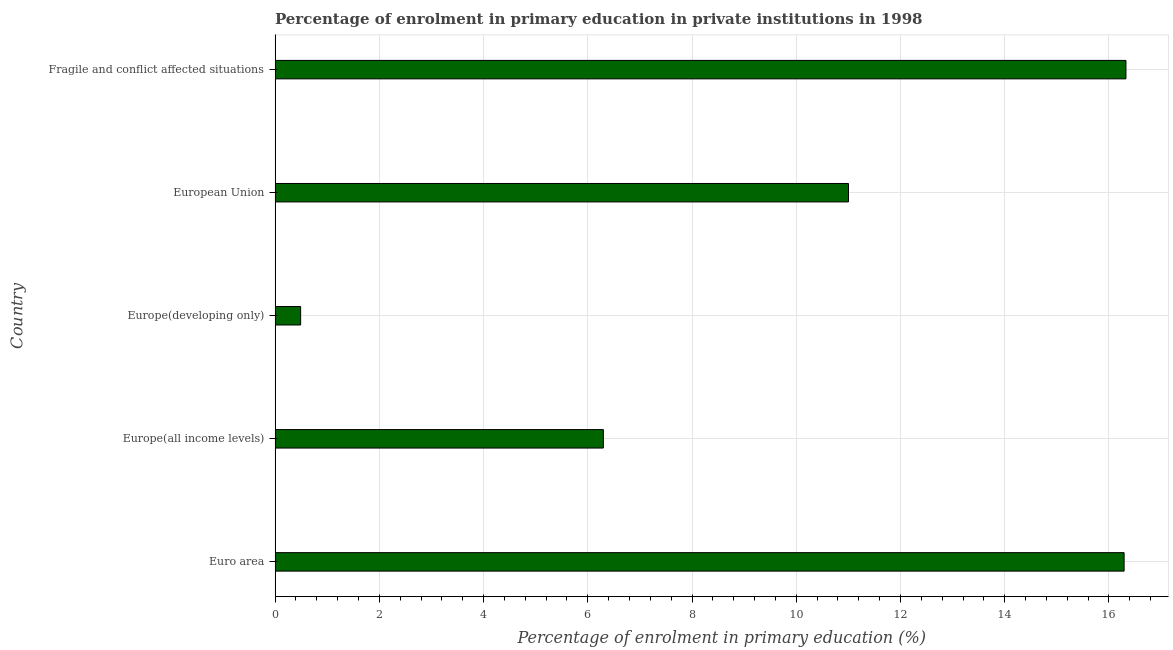What is the title of the graph?
Provide a succinct answer. Percentage of enrolment in primary education in private institutions in 1998. What is the label or title of the X-axis?
Provide a succinct answer. Percentage of enrolment in primary education (%). What is the enrolment percentage in primary education in Europe(developing only)?
Offer a terse response. 0.49. Across all countries, what is the maximum enrolment percentage in primary education?
Make the answer very short. 16.33. Across all countries, what is the minimum enrolment percentage in primary education?
Provide a succinct answer. 0.49. In which country was the enrolment percentage in primary education maximum?
Provide a succinct answer. Fragile and conflict affected situations. In which country was the enrolment percentage in primary education minimum?
Offer a terse response. Europe(developing only). What is the sum of the enrolment percentage in primary education?
Your answer should be compact. 50.41. What is the difference between the enrolment percentage in primary education in Europe(all income levels) and European Union?
Give a very brief answer. -4.7. What is the average enrolment percentage in primary education per country?
Give a very brief answer. 10.08. What is the median enrolment percentage in primary education?
Your answer should be compact. 11. What is the ratio of the enrolment percentage in primary education in Euro area to that in European Union?
Ensure brevity in your answer.  1.48. Is the difference between the enrolment percentage in primary education in Euro area and Europe(developing only) greater than the difference between any two countries?
Make the answer very short. No. What is the difference between the highest and the second highest enrolment percentage in primary education?
Your answer should be compact. 0.04. Is the sum of the enrolment percentage in primary education in Euro area and Europe(developing only) greater than the maximum enrolment percentage in primary education across all countries?
Provide a succinct answer. Yes. What is the difference between the highest and the lowest enrolment percentage in primary education?
Your response must be concise. 15.84. What is the difference between two consecutive major ticks on the X-axis?
Your response must be concise. 2. What is the Percentage of enrolment in primary education (%) of Euro area?
Make the answer very short. 16.29. What is the Percentage of enrolment in primary education (%) of Europe(all income levels)?
Give a very brief answer. 6.3. What is the Percentage of enrolment in primary education (%) of Europe(developing only)?
Your answer should be very brief. 0.49. What is the Percentage of enrolment in primary education (%) in European Union?
Offer a very short reply. 11. What is the Percentage of enrolment in primary education (%) of Fragile and conflict affected situations?
Give a very brief answer. 16.33. What is the difference between the Percentage of enrolment in primary education (%) in Euro area and Europe(all income levels)?
Make the answer very short. 9.99. What is the difference between the Percentage of enrolment in primary education (%) in Euro area and Europe(developing only)?
Offer a very short reply. 15.8. What is the difference between the Percentage of enrolment in primary education (%) in Euro area and European Union?
Keep it short and to the point. 5.29. What is the difference between the Percentage of enrolment in primary education (%) in Euro area and Fragile and conflict affected situations?
Your response must be concise. -0.04. What is the difference between the Percentage of enrolment in primary education (%) in Europe(all income levels) and Europe(developing only)?
Keep it short and to the point. 5.81. What is the difference between the Percentage of enrolment in primary education (%) in Europe(all income levels) and European Union?
Ensure brevity in your answer.  -4.7. What is the difference between the Percentage of enrolment in primary education (%) in Europe(all income levels) and Fragile and conflict affected situations?
Ensure brevity in your answer.  -10.03. What is the difference between the Percentage of enrolment in primary education (%) in Europe(developing only) and European Union?
Your response must be concise. -10.51. What is the difference between the Percentage of enrolment in primary education (%) in Europe(developing only) and Fragile and conflict affected situations?
Provide a short and direct response. -15.84. What is the difference between the Percentage of enrolment in primary education (%) in European Union and Fragile and conflict affected situations?
Make the answer very short. -5.32. What is the ratio of the Percentage of enrolment in primary education (%) in Euro area to that in Europe(all income levels)?
Keep it short and to the point. 2.59. What is the ratio of the Percentage of enrolment in primary education (%) in Euro area to that in Europe(developing only)?
Your answer should be compact. 33.22. What is the ratio of the Percentage of enrolment in primary education (%) in Euro area to that in European Union?
Make the answer very short. 1.48. What is the ratio of the Percentage of enrolment in primary education (%) in Euro area to that in Fragile and conflict affected situations?
Offer a terse response. 1. What is the ratio of the Percentage of enrolment in primary education (%) in Europe(all income levels) to that in Europe(developing only)?
Offer a terse response. 12.84. What is the ratio of the Percentage of enrolment in primary education (%) in Europe(all income levels) to that in European Union?
Your answer should be compact. 0.57. What is the ratio of the Percentage of enrolment in primary education (%) in Europe(all income levels) to that in Fragile and conflict affected situations?
Ensure brevity in your answer.  0.39. What is the ratio of the Percentage of enrolment in primary education (%) in Europe(developing only) to that in European Union?
Your answer should be very brief. 0.04. What is the ratio of the Percentage of enrolment in primary education (%) in Europe(developing only) to that in Fragile and conflict affected situations?
Give a very brief answer. 0.03. What is the ratio of the Percentage of enrolment in primary education (%) in European Union to that in Fragile and conflict affected situations?
Offer a terse response. 0.67. 